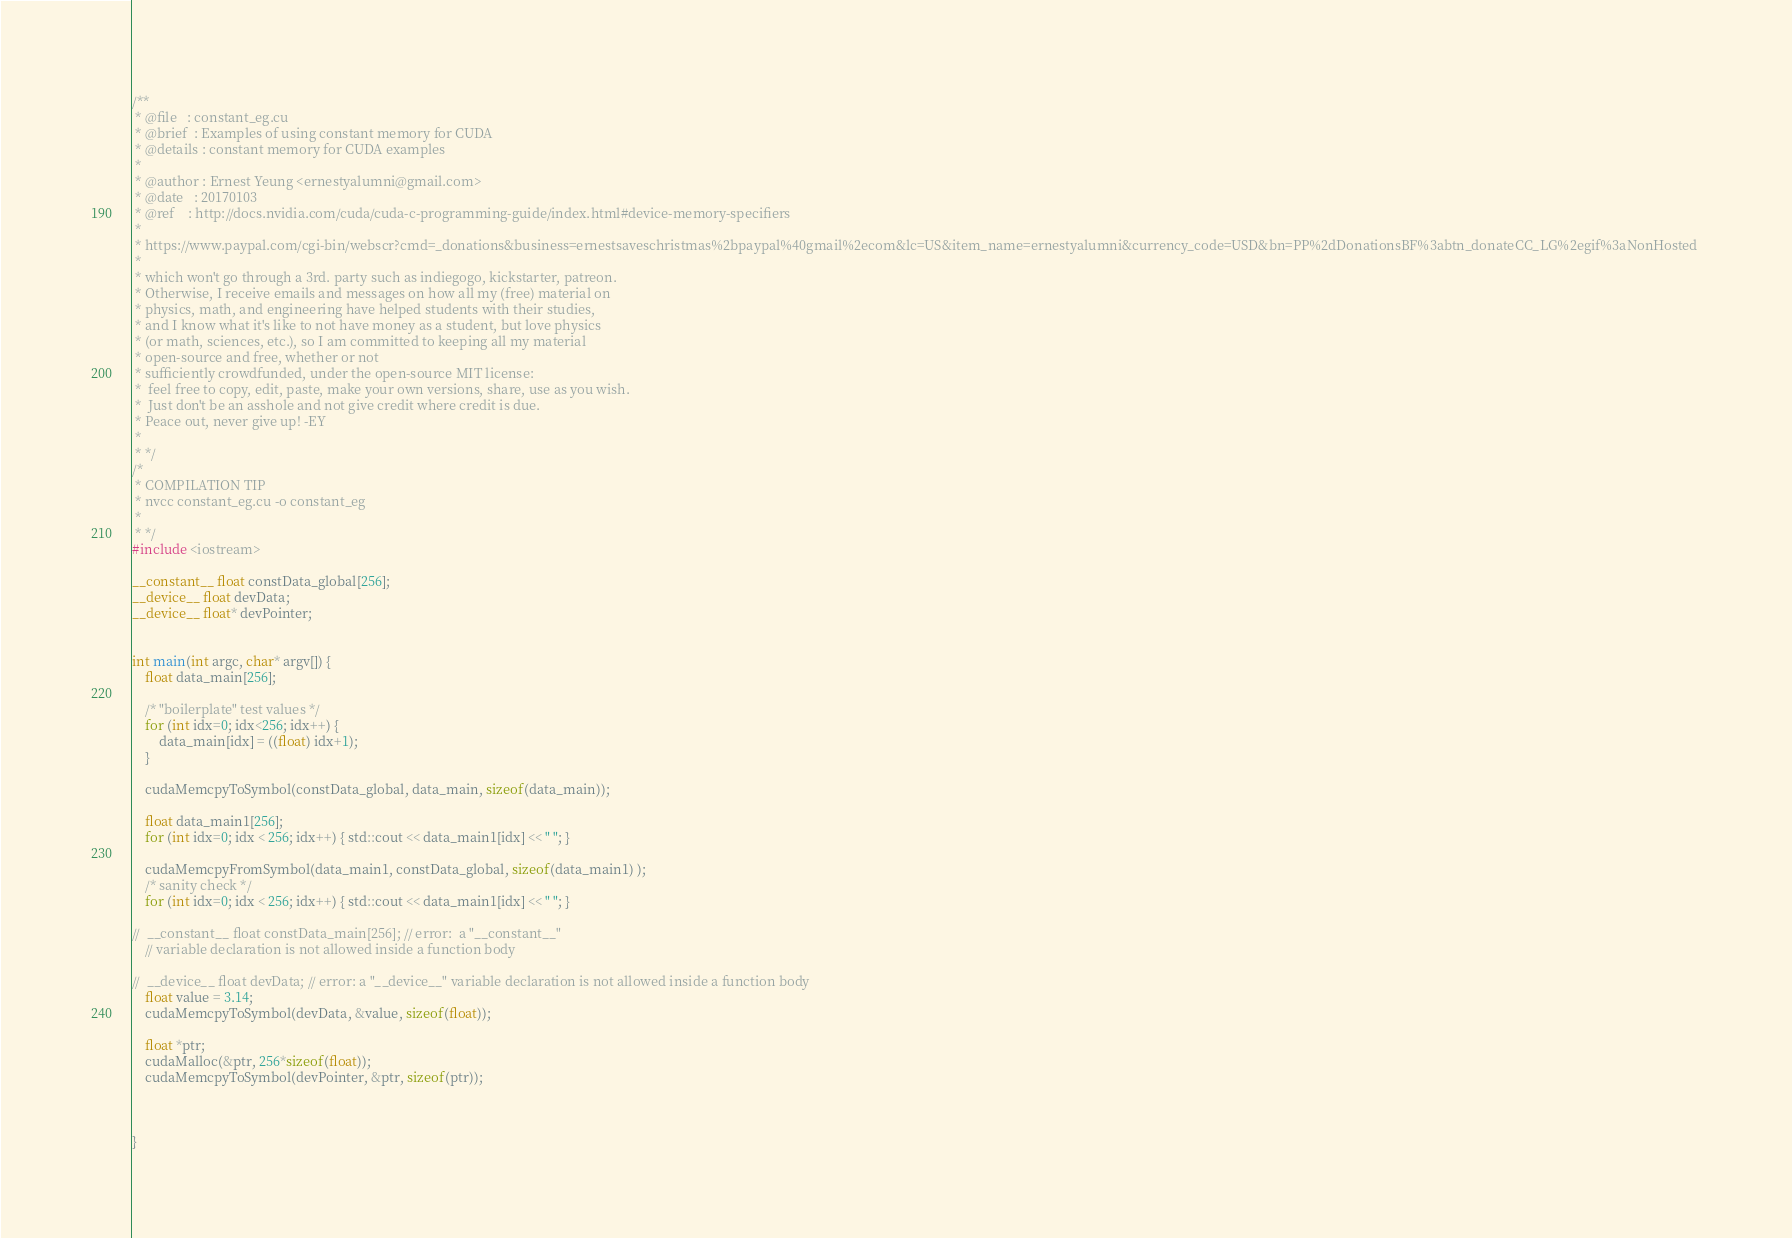Convert code to text. <code><loc_0><loc_0><loc_500><loc_500><_Cuda_>/**
 * @file   : constant_eg.cu
 * @brief  : Examples of using constant memory for CUDA 
 * @details : constant memory for CUDA examples
 *  
 * @author : Ernest Yeung <ernestyalumni@gmail.com>
 * @date   : 20170103      
 * @ref    : http://docs.nvidia.com/cuda/cuda-c-programming-guide/index.html#device-memory-specifiers
 * 
 * https://www.paypal.com/cgi-bin/webscr?cmd=_donations&business=ernestsaveschristmas%2bpaypal%40gmail%2ecom&lc=US&item_name=ernestyalumni&currency_code=USD&bn=PP%2dDonationsBF%3abtn_donateCC_LG%2egif%3aNonHosted 
 * 
 * which won't go through a 3rd. party such as indiegogo, kickstarter, patreon.  
 * Otherwise, I receive emails and messages on how all my (free) material on 
 * physics, math, and engineering have helped students with their studies, 
 * and I know what it's like to not have money as a student, but love physics 
 * (or math, sciences, etc.), so I am committed to keeping all my material 
 * open-source and free, whether or not 
 * sufficiently crowdfunded, under the open-source MIT license: 
 * 	feel free to copy, edit, paste, make your own versions, share, use as you wish.  
 *  Just don't be an asshole and not give credit where credit is due.  
 * Peace out, never give up! -EY
 * 
 * */
/* 
 * COMPILATION TIP
 * nvcc constant_eg.cu -o constant_eg
 * 
 * */
#include <iostream>   

__constant__ float constData_global[256]; 
__device__ float devData;  
__device__ float* devPointer; 


int main(int argc, char* argv[]) {
	float data_main[256]; 

	/* "boilerplate" test values */ 
	for (int idx=0; idx<256; idx++) { 
		data_main[idx] = ((float) idx+1);  
	}
	
	cudaMemcpyToSymbol(constData_global, data_main, sizeof(data_main)); 
	
	float data_main1[256]; 
	for (int idx=0; idx < 256; idx++) { std::cout << data_main1[idx] << " "; }

	cudaMemcpyFromSymbol(data_main1, constData_global, sizeof(data_main1) );
	/* sanity check */ 
	for (int idx=0; idx < 256; idx++) { std::cout << data_main1[idx] << " "; }
	
//	__constant__ float constData_main[256]; // error:  a "__constant__" 
	// variable declaration is not allowed inside a function body

//	__device__ float devData; // error: a "__device__" variable declaration is not allowed inside a function body
	float value = 3.14; 
	cudaMemcpyToSymbol(devData, &value, sizeof(float)); 
	
	float *ptr; 
	cudaMalloc(&ptr, 256*sizeof(float)); 
	cudaMemcpyToSymbol(devPointer, &ptr, sizeof(ptr));  
	
	

}
</code> 